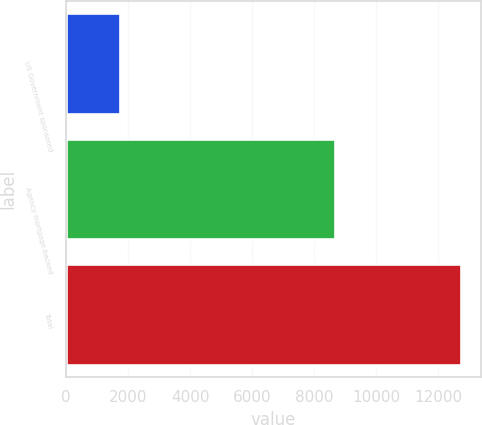Convert chart. <chart><loc_0><loc_0><loc_500><loc_500><bar_chart><fcel>US Government sponsored<fcel>Agency mortgage-backed<fcel>Total<nl><fcel>1730<fcel>8681<fcel>12728<nl></chart> 